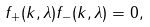<formula> <loc_0><loc_0><loc_500><loc_500>f _ { + } ( k , \lambda ) f _ { - } ( k , \lambda ) = 0 ,</formula> 